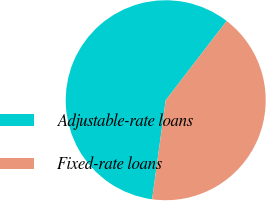<chart> <loc_0><loc_0><loc_500><loc_500><pie_chart><fcel>Adjustable-rate loans<fcel>Fixed-rate loans<nl><fcel>58.26%<fcel>41.74%<nl></chart> 